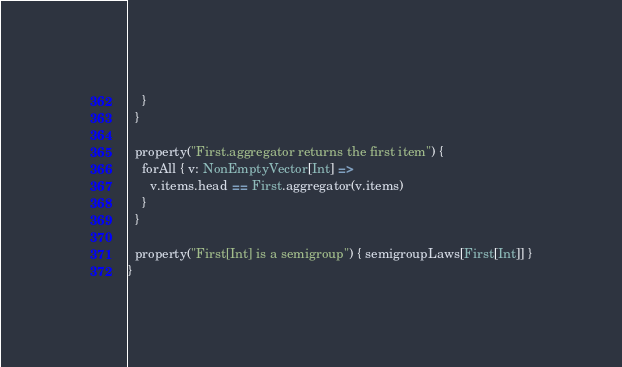Convert code to text. <code><loc_0><loc_0><loc_500><loc_500><_Scala_>    }
  }

  property("First.aggregator returns the first item") {
    forAll { v: NonEmptyVector[Int] =>
      v.items.head == First.aggregator(v.items)
    }
  }

  property("First[Int] is a semigroup") { semigroupLaws[First[Int]] }
}
</code> 